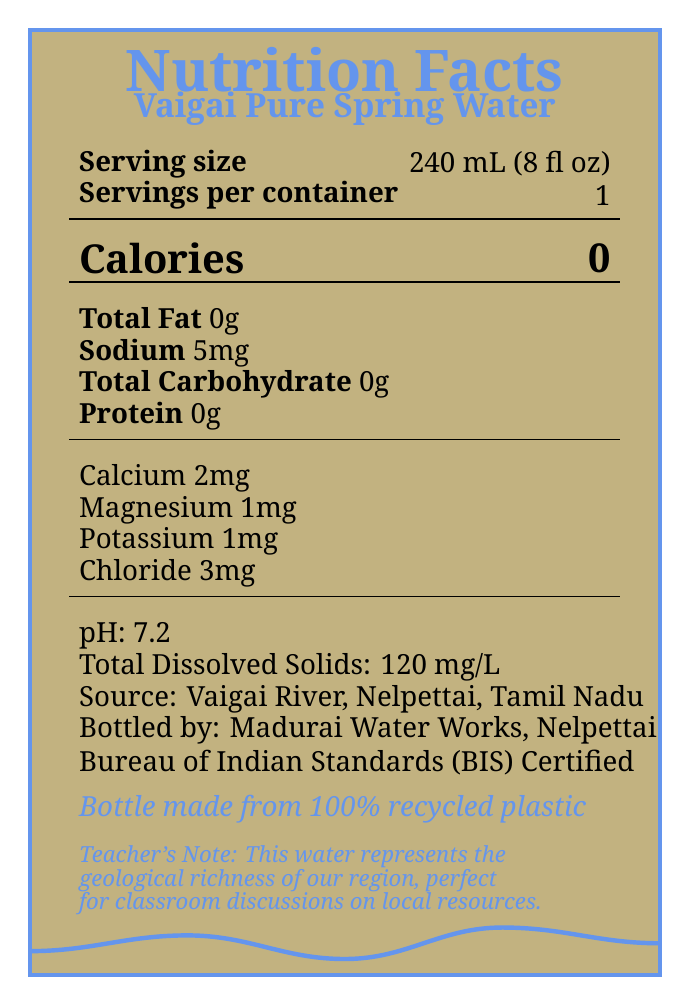what is the serving size for Vaigai Pure Spring Water? The Nutrition Facts Label specifies the serving size as 240 mL (8 fl oz).
Answer: 240 mL (8 fl oz) how much sodium is in one serving? The label indicates that the sodium content in one serving is 5 mg.
Answer: 5 mg how many calories does Vaigai Pure Spring Water contain per serving? According to the label, there are 0 calories per serving.
Answer: 0 what is the pH level of Vaigai Pure Spring Water? The Nutrition Facts Label lists the pH level as 7.2.
Answer: 7.2 what is the calcium content in one serving? The label shows that one serving contains 2 mg of calcium.
Answer: 2 mg who bottles Vaigai Pure Spring Water? The label states that the water is bottled by Madurai Water Works, Nelpettai.
Answer: Madurai Water Works, Nelpettai what is the source of Vaigai Pure Spring Water? The source is specified as the Vaigai River, Nelpettai, Tamil Nadu.
Answer: Vaigai River, Nelpettai, Tamil Nadu how many total dissolved solids are in the water? The label mentions that there are 120 mg/L of total dissolved solids.
Answer: 120 mg/L which certification does Vaigai Pure Spring Water have? A. ISO B. USDA Organic C. Bureau of Indian Standards (BIS) Certified The label indicates that it is certified by the Bureau of Indian Standards (BIS).
Answer: C how many servings are in one container of Vaigai Pure Spring Water? A. 1 B. 2 C. 3 D. 4 The label specifies that there is 1 serving per container.
Answer: A is the bottle made from recycled materials? The label indicates that the bottle is made from 100% recycled plastic.
Answer: Yes describe the main idea of the document The document summarizes the nutrition, source, and additional details of Vaigai Pure Spring Water, emphasizing both its health benefits and regional importance.
Answer: The Nutrition Facts Label for Vaigai Pure Spring Water provides detailed information about serving size, nutritional content (including calories, fats, sodium, and minerals), pH level, total dissolved solids, source, bottler, certification, and environmental impact. The document also highlights interesting facts about the Vaigai River and its significance to the local economy and education. what is the specific historical significance of the Vaigai River mentioned in the document? The document mentions that the Vaigai River has been a lifeline for Nelpettai for centuries and includes local folklore about its healing properties, but it does not provide specific historical events.
Answer: Not enough information how does the label describe Vaigai River's water filtration? The label mentions that the water is naturally filtered through layers of ancient rock formations.
Answer: Naturally filtered through layers of ancient rock formations what is the potassium content in one serving? The Nutrition Facts Label indicates that there is 1 mg of potassium per serving.
Answer: 1 mg why is Vaigai Pure Spring Water significant to the local economy? The label states that the water supports the local economy and reduces the carbon footprint from transportation.
Answer: Supports local economy and reduces carbon footprint from transportation 